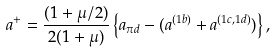Convert formula to latex. <formula><loc_0><loc_0><loc_500><loc_500>a ^ { + } = \frac { ( 1 + { \mu / 2 } ) } { 2 ( 1 + \mu ) } \left \{ a _ { \pi d } - ( { a ^ { ( 1 b ) } } + { a ^ { ( 1 c , 1 d ) } } ) \right \} ,</formula> 